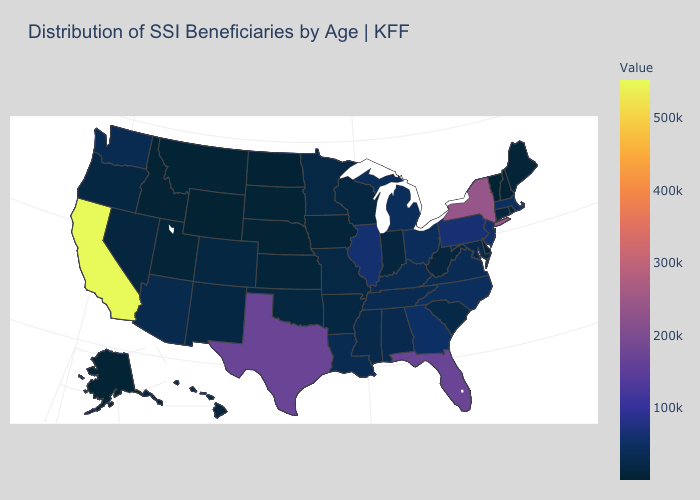Which states have the lowest value in the USA?
Concise answer only. Wyoming. Does Nevada have a higher value than California?
Quick response, please. No. Among the states that border Louisiana , does Arkansas have the highest value?
Answer briefly. No. Does California have the highest value in the USA?
Be succinct. Yes. Among the states that border New York , which have the lowest value?
Be succinct. Vermont. Among the states that border Nevada , does Utah have the highest value?
Be succinct. No. Which states have the lowest value in the USA?
Be succinct. Wyoming. Among the states that border Texas , which have the lowest value?
Quick response, please. Oklahoma. 